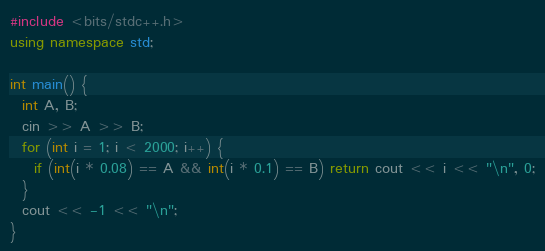<code> <loc_0><loc_0><loc_500><loc_500><_C++_>#include <bits/stdc++.h>
using namespace std;

int main() {
  int A, B;
  cin >> A >> B;
  for (int i = 1; i < 2000; i++) {
    if (int(i * 0.08) == A && int(i * 0.1) == B) return cout << i << "\n", 0;
  }
  cout << -1 << "\n";
}</code> 